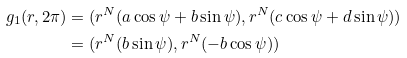Convert formula to latex. <formula><loc_0><loc_0><loc_500><loc_500>g _ { 1 } ( r , 2 \pi ) & = ( r ^ { N } ( a \cos \psi + b \sin \psi ) , r ^ { N } ( c \cos \psi + d \sin \psi ) ) \\ & = ( r ^ { N } ( b \sin \psi ) , r ^ { N } ( - b \cos \psi ) )</formula> 